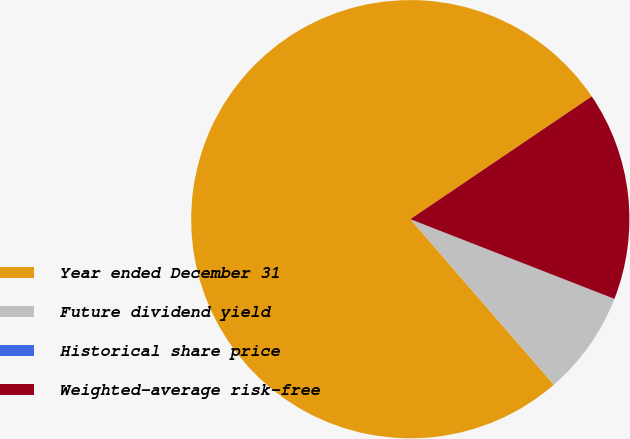Convert chart to OTSL. <chart><loc_0><loc_0><loc_500><loc_500><pie_chart><fcel>Year ended December 31<fcel>Future dividend yield<fcel>Historical share price<fcel>Weighted-average risk-free<nl><fcel>76.9%<fcel>7.7%<fcel>0.01%<fcel>15.39%<nl></chart> 